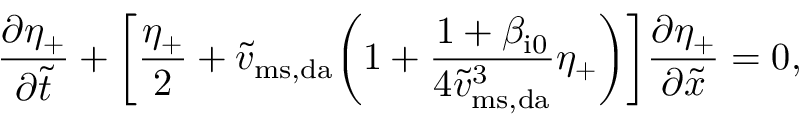<formula> <loc_0><loc_0><loc_500><loc_500>\frac { \partial \eta _ { + } } { \partial \widetilde { t } } + \left [ \frac { \eta _ { + } } { 2 } + \widetilde { v } _ { m s , d a } \left ( 1 + \frac { 1 + \beta _ { i 0 } } { 4 \widetilde { v } _ { m s , d a } ^ { 3 } } \eta _ { + } \right ) \right ] \frac { \partial \eta _ { + } } { \partial \widetilde { x } } = 0 ,</formula> 